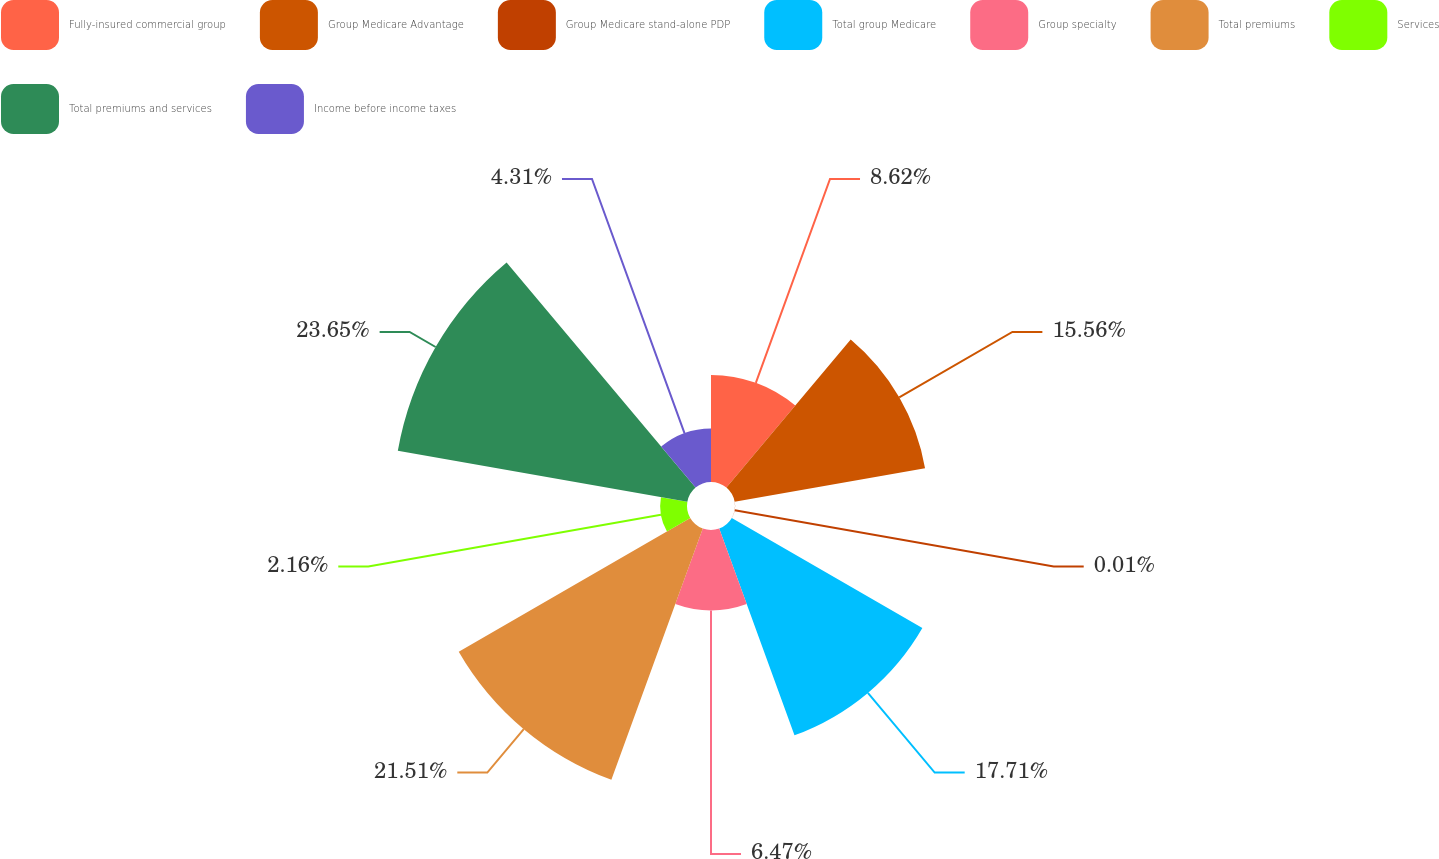Convert chart to OTSL. <chart><loc_0><loc_0><loc_500><loc_500><pie_chart><fcel>Fully-insured commercial group<fcel>Group Medicare Advantage<fcel>Group Medicare stand-alone PDP<fcel>Total group Medicare<fcel>Group specialty<fcel>Total premiums<fcel>Services<fcel>Total premiums and services<fcel>Income before income taxes<nl><fcel>8.62%<fcel>15.56%<fcel>0.01%<fcel>17.71%<fcel>6.47%<fcel>21.51%<fcel>2.16%<fcel>23.66%<fcel>4.31%<nl></chart> 